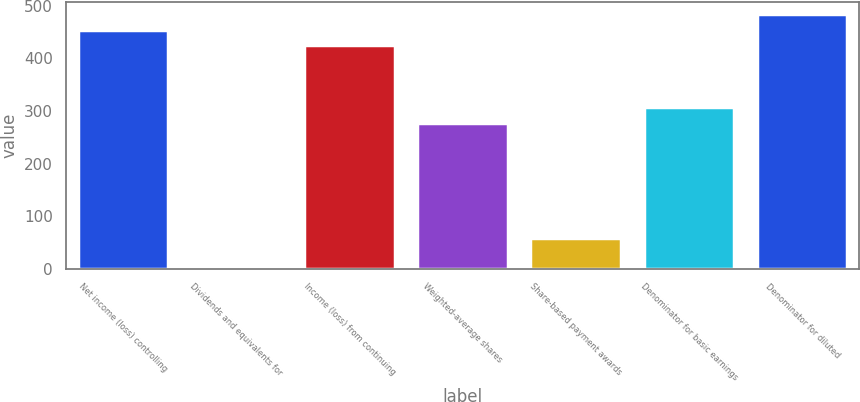<chart> <loc_0><loc_0><loc_500><loc_500><bar_chart><fcel>Net income (loss) controlling<fcel>Dividends and equivalents for<fcel>Income (loss) from continuing<fcel>Weighted-average shares<fcel>Share-based payment awards<fcel>Denominator for basic earnings<fcel>Denominator for diluted<nl><fcel>454.22<fcel>0.2<fcel>424.8<fcel>277.7<fcel>59.04<fcel>307.12<fcel>483.64<nl></chart> 